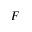Convert formula to latex. <formula><loc_0><loc_0><loc_500><loc_500>F</formula> 